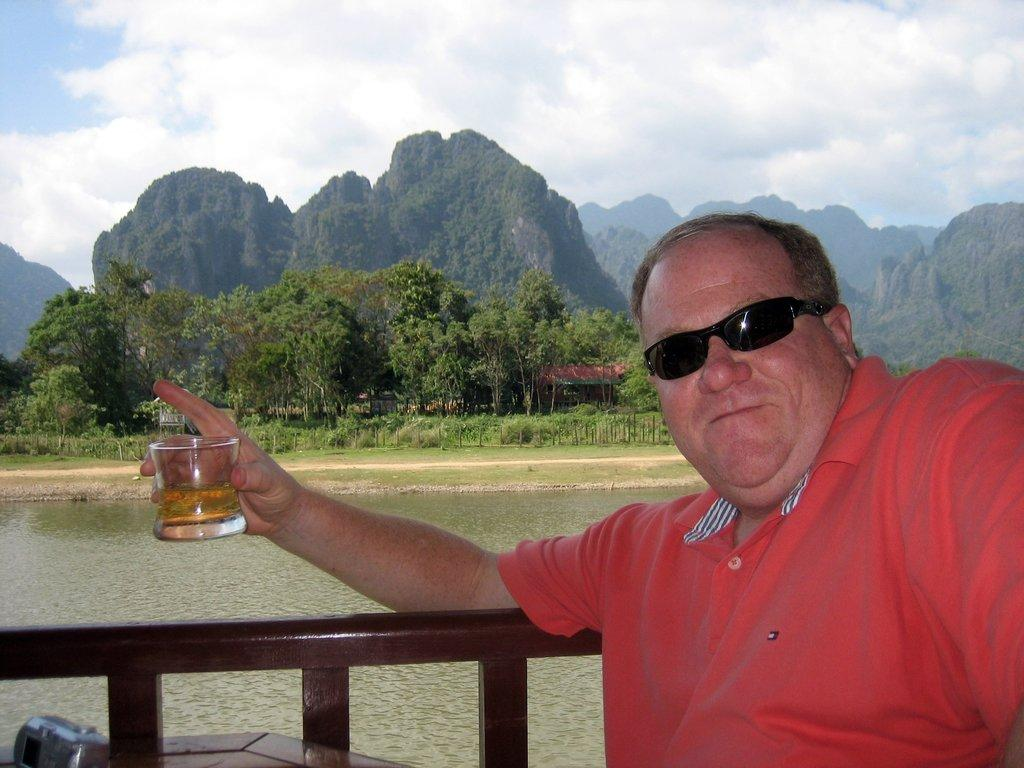What is the man in the image holding? The man is holding a glass of drink. What can be seen at the bottom of the image? There is water visible at the bottom of the image. What is visible in the background of the image? There are hills and trees in the background of the image. What is visible at the top of the image? The sky is visible at the top of the image. What color is the crayon that the man is using to draw in the image? There is no crayon present in the image, and the man is not drawing. 